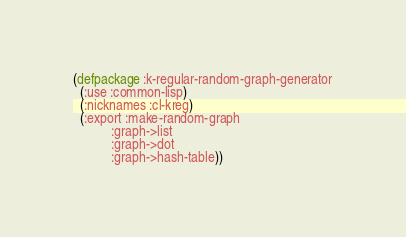Convert code to text. <code><loc_0><loc_0><loc_500><loc_500><_Lisp_>(defpackage :k-regular-random-graph-generator
  (:use :common-lisp) 
  (:nicknames :cl-kreg) 
  (:export :make-random-graph
           :graph->list
           :graph->dot
           :graph->hash-table))
</code> 